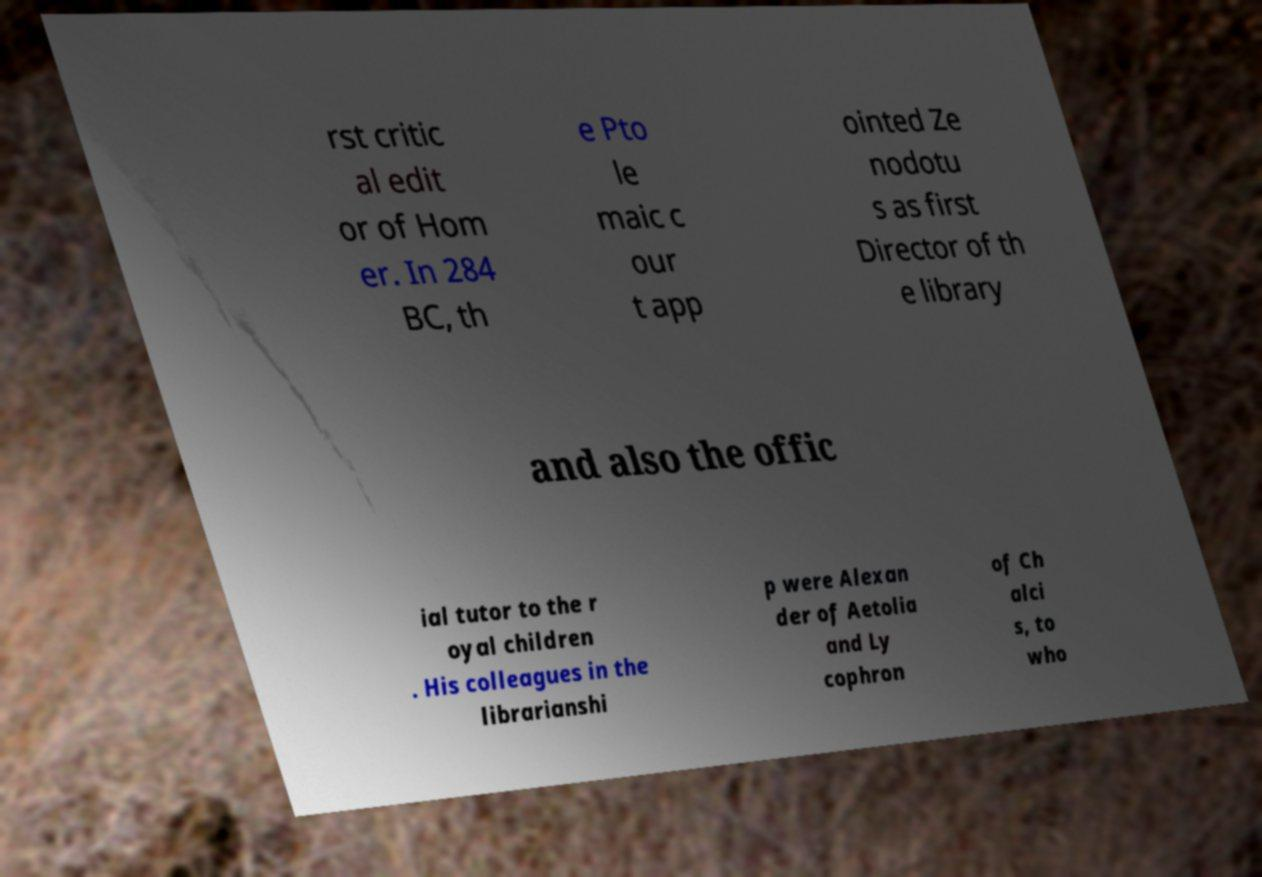What messages or text are displayed in this image? I need them in a readable, typed format. rst critic al edit or of Hom er. In 284 BC, th e Pto le maic c our t app ointed Ze nodotu s as first Director of th e library and also the offic ial tutor to the r oyal children . His colleagues in the librarianshi p were Alexan der of Aetolia and Ly cophron of Ch alci s, to who 